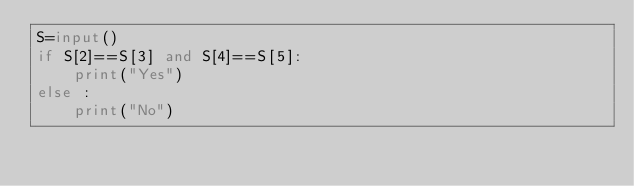<code> <loc_0><loc_0><loc_500><loc_500><_Python_>S=input()
if S[2]==S[3] and S[4]==S[5]:
    print("Yes")
else : 
    print("No")

</code> 